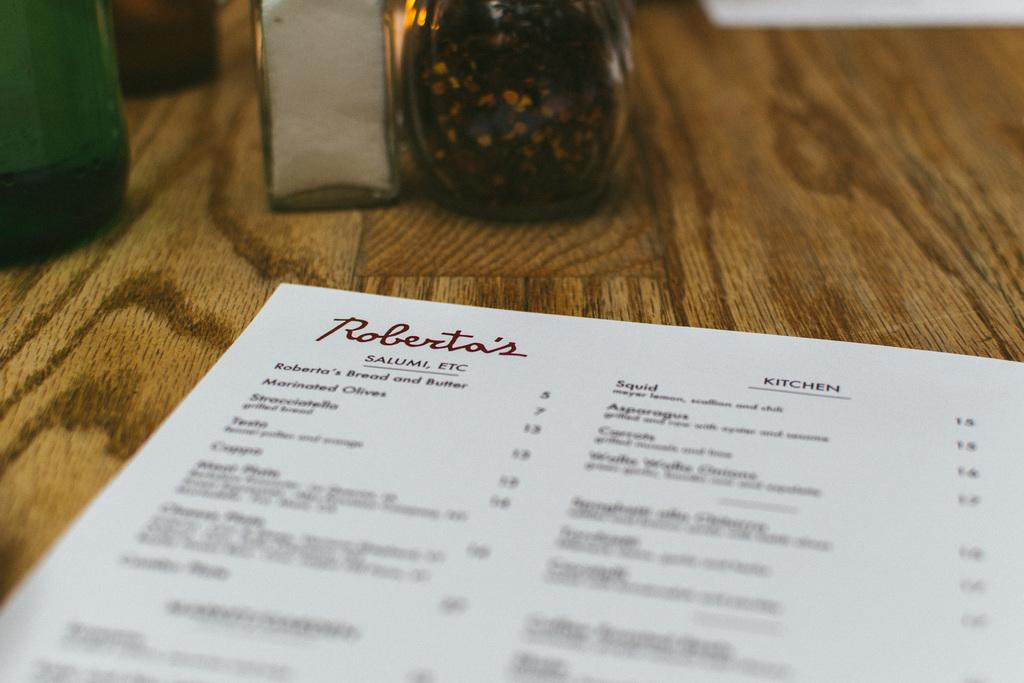What is the color of the surface in the image? The surface in the image is brown colored. What objects can be seen on the surface? There are two pieces of paper and green, white, and brown bottles on the surface. What type of offer is being made in the image? There is no offer being made in the image; it only contains a brown surface with two pieces of paper and bottles. 